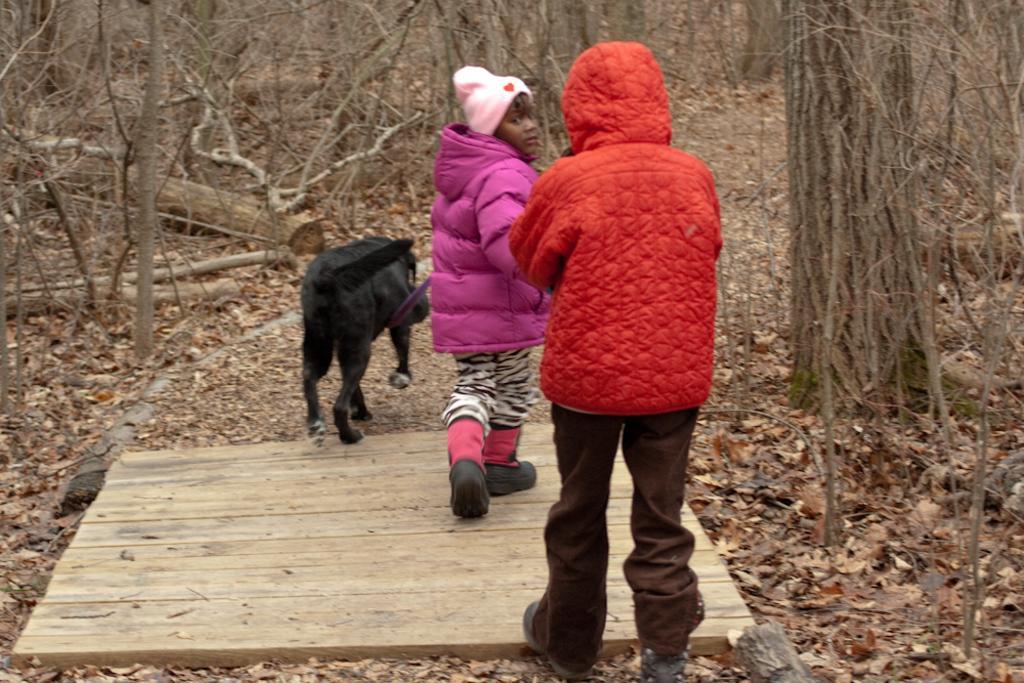How would you summarize this image in a sentence or two? In this picture, we can see there are two kids on the wooden path and the kid in the pink jacket is holding a dog belt and in front of the kids there is a dog, dry leaves and trees. 